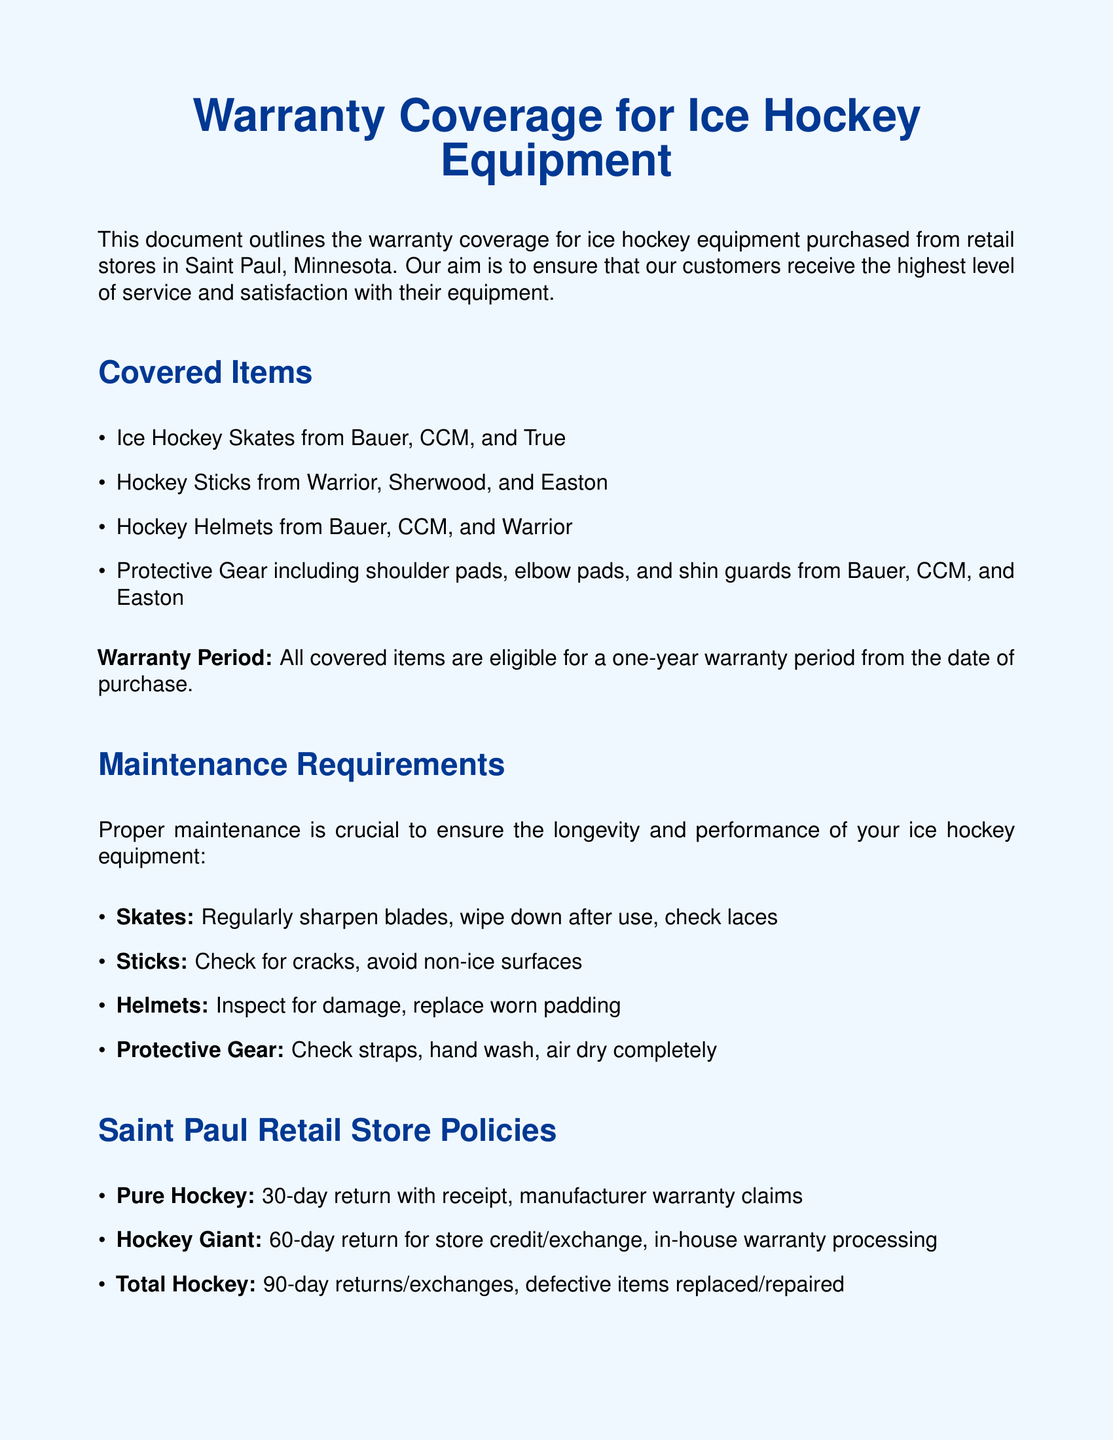What is the warranty period for covered items? The warranty period for all covered items is one year from the date of purchase.
Answer: one year Which brands of ice hockey skates are covered? The document lists Bauer, CCM, and True as the brands of ice hockey skates that are covered.
Answer: Bauer, CCM, and True What maintenance is required for hockey sticks? The maintenance required for hockey sticks includes checking for cracks and avoiding non-ice surfaces.
Answer: Check for cracks, avoid non-ice surfaces What is Pure Hockey's return policy? Pure Hockey offers a 30-day return policy with receipt and processes manufacturer warranty claims.
Answer: 30-day return with receipt How long is the return period at Hockey Giant? The return period at Hockey Giant is stated to be 60 days for store credit or exchange.
Answer: 60-day return What should you do with protective gear after washing? The document advises to air dry the protective gear completely after washing it.
Answer: Air dry completely What should you do if your helmet padding is worn? The maintenance detail suggests replacing worn padding in the helmet.
Answer: Replace worn padding Where can you contact for warranty inquiries? The contact information for warranty inquiries includes an email address and phone number provided in the document.
Answer: customerservice@saintpaulhockey.com and 651-555-1234 